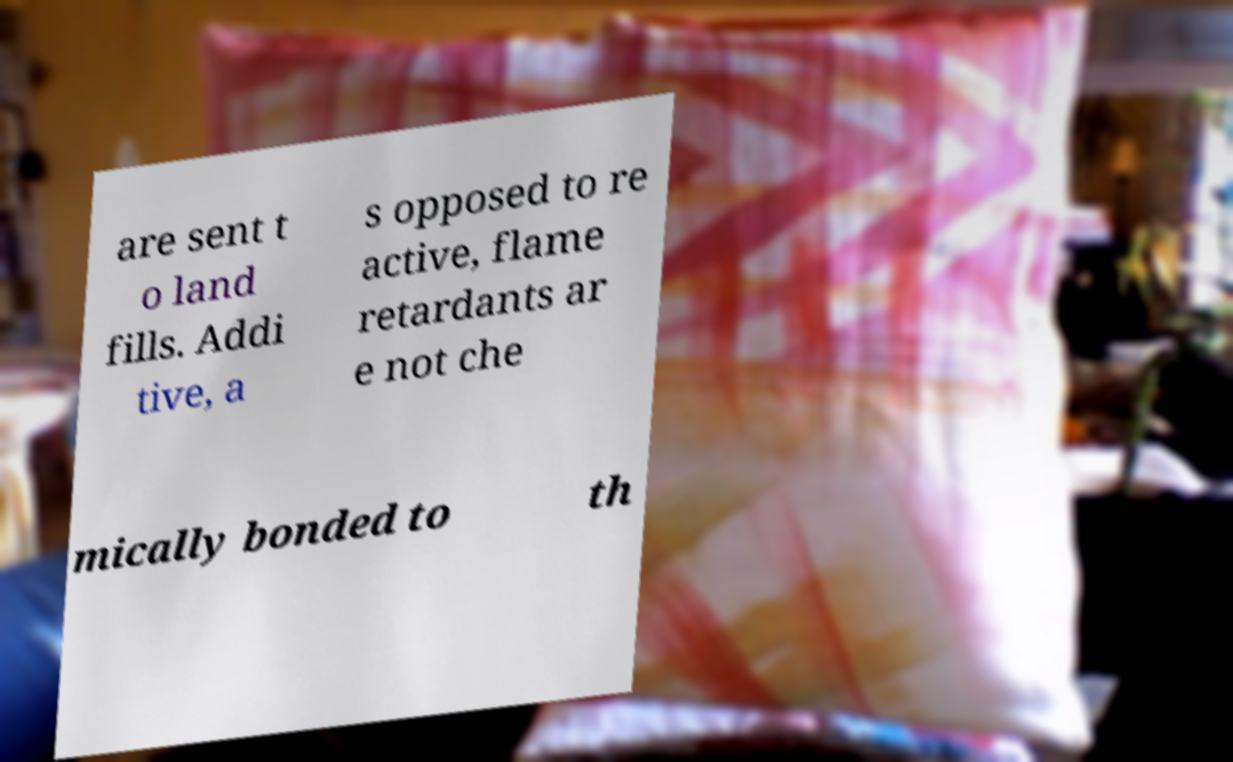Please identify and transcribe the text found in this image. are sent t o land fills. Addi tive, a s opposed to re active, flame retardants ar e not che mically bonded to th 